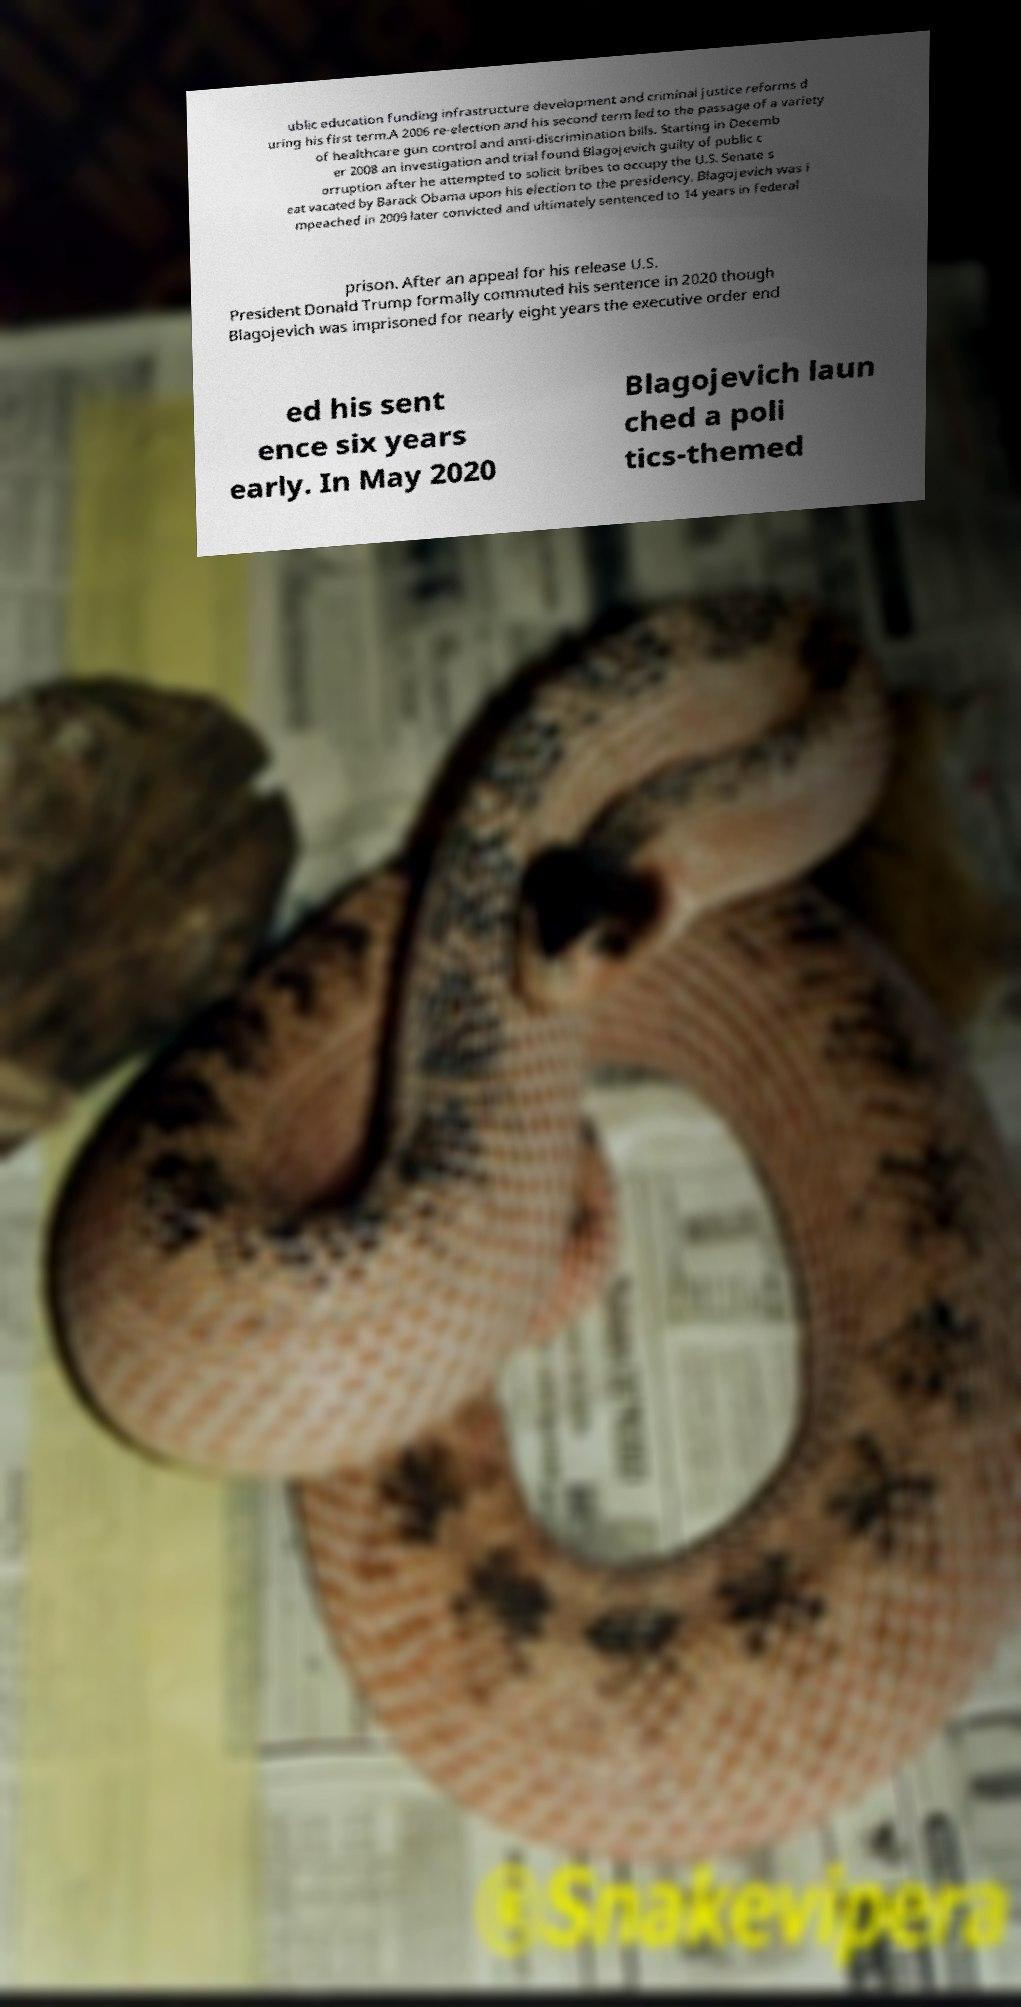Could you extract and type out the text from this image? ublic education funding infrastructure development and criminal justice reforms d uring his first term.A 2006 re-election and his second term led to the passage of a variety of healthcare gun control and anti-discrimination bills. Starting in Decemb er 2008 an investigation and trial found Blagojevich guilty of public c orruption after he attempted to solicit bribes to occupy the U.S. Senate s eat vacated by Barack Obama upon his election to the presidency. Blagojevich was i mpeached in 2009 later convicted and ultimately sentenced to 14 years in federal prison. After an appeal for his release U.S. President Donald Trump formally commuted his sentence in 2020 though Blagojevich was imprisoned for nearly eight years the executive order end ed his sent ence six years early. In May 2020 Blagojevich laun ched a poli tics-themed 